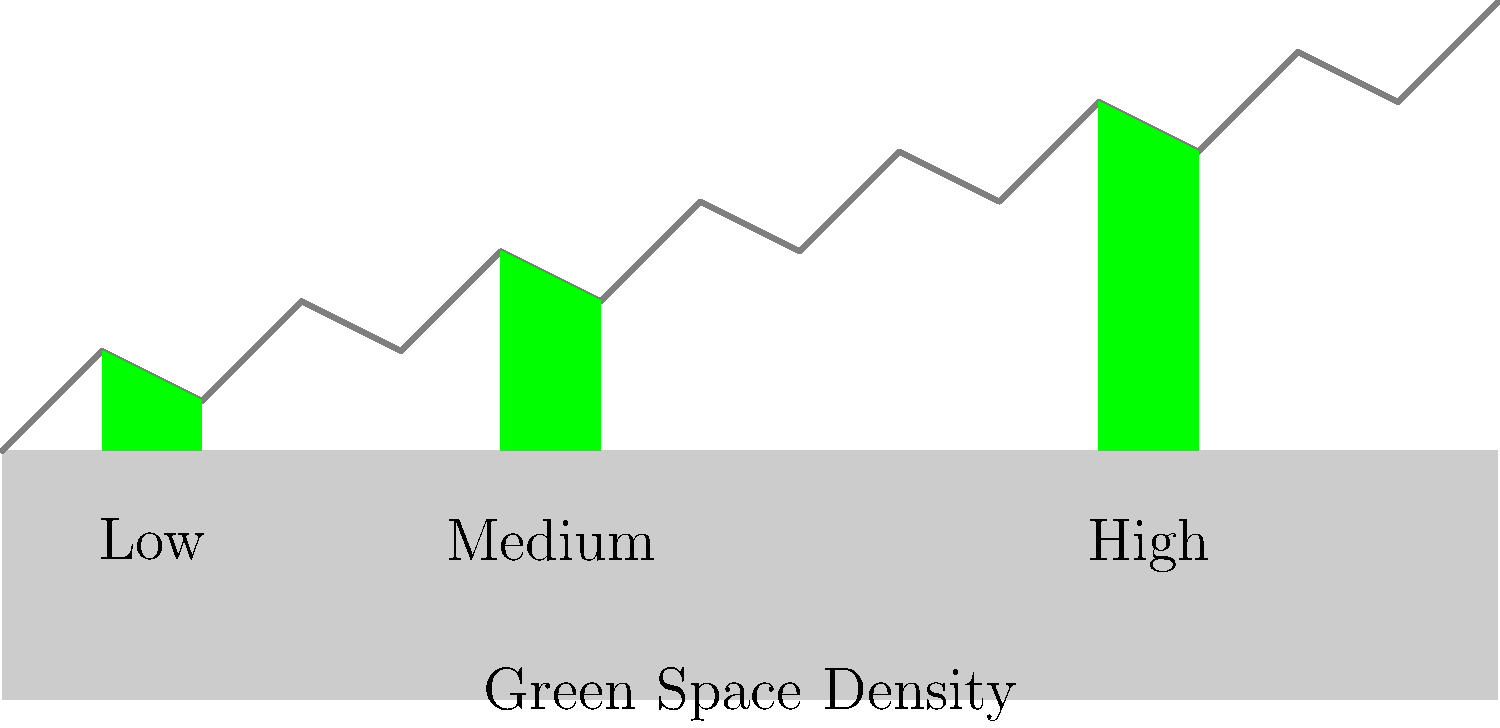In the context of urban planning and societal well-being, analyze the cross-section of the city depicted above. How might the varying densities of green spaces impact the mental health of residents in different areas, and what sociological implications could this have for your next theatrical production? 1. Observe the city cross-section:
   - The image shows three distinct areas with varying green space densities: low, medium, and high.

2. Analyze the green space impact:
   - Low density: Minimal green space, potentially leading to higher stress levels and reduced well-being.
   - Medium density: Moderate green space, likely offering some mental health benefits.
   - High density: Abundant green space, potentially providing significant mental health improvements.

3. Consider the mental health indicators:
   - The arrows above each section indicate the relative mental health impact.
   - Longer arrows correspond to more positive mental health outcomes.

4. Sociological implications:
   - Urban inequality: Different access to green spaces may reflect socioeconomic disparities.
   - Community cohesion: Green spaces can foster social interactions and strengthen community bonds.
   - Public health: Unequal distribution of green spaces may lead to health inequalities across neighborhoods.

5. Theatrical production considerations:
   - Character development: Create characters from different areas to explore varying mental states.
   - Setting: Use contrasting urban environments to highlight the impact of green spaces.
   - Conflict: Explore tensions between residents of different areas or urban development vs. preservation of green spaces.
   - Themes: Address issues of urban planning, environmental justice, and community well-being.

6. Potential storylines:
   - A tale of two neighborhoods: Contrast the lives of characters from low and high green space density areas.
   - Grassroots movement: Depict a community's struggle to increase green spaces in their neighborhood.
   - Urban planner's dilemma: Explore the challenges of balancing development with the need for green spaces.
Answer: Increased green space density correlates with improved mental health, highlighting urban inequalities and potential themes for a socially conscious theatrical production. 